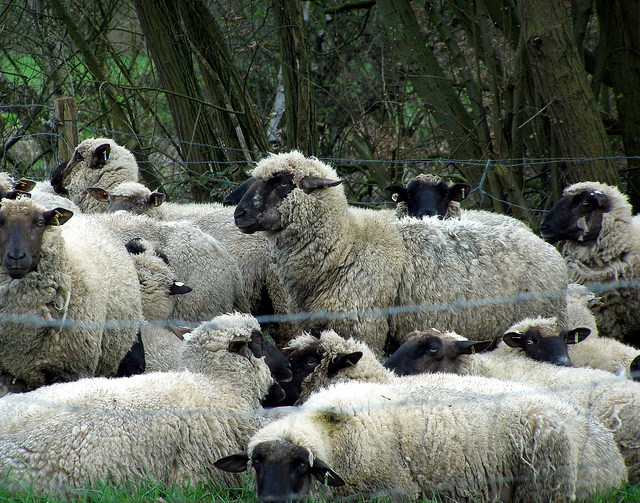Are there any other animals or objects of interest in the image? The primary focus of the image is the group of sheep. Additionally, there is a fence clearly visible in the foreground and dense trees and plants form the background scenery, giving the image a lush, rustic feel. No other animals or prominent objects seem to be in the frame. 